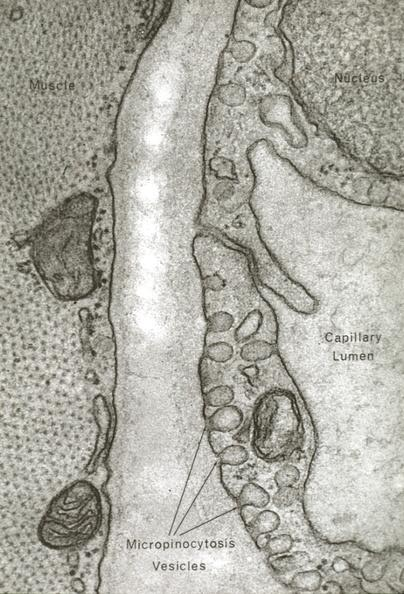does polycystic disease show skeletal muscle?
Answer the question using a single word or phrase. No 